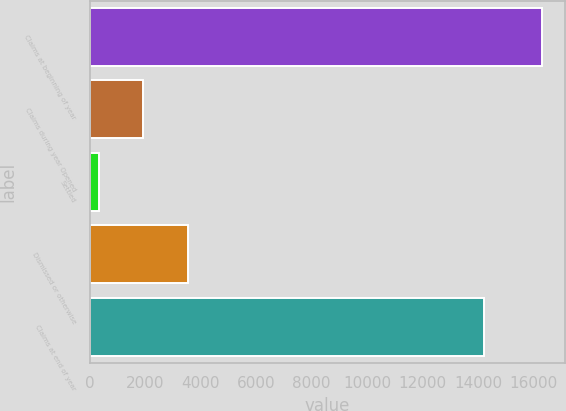Convert chart to OTSL. <chart><loc_0><loc_0><loc_500><loc_500><bar_chart><fcel>Claims at beginning of year<fcel>Claims during year Opened<fcel>Settled<fcel>Dismissed or otherwise<fcel>Claims at end of year<nl><fcel>16320<fcel>1928.1<fcel>329<fcel>3527.2<fcel>14215<nl></chart> 